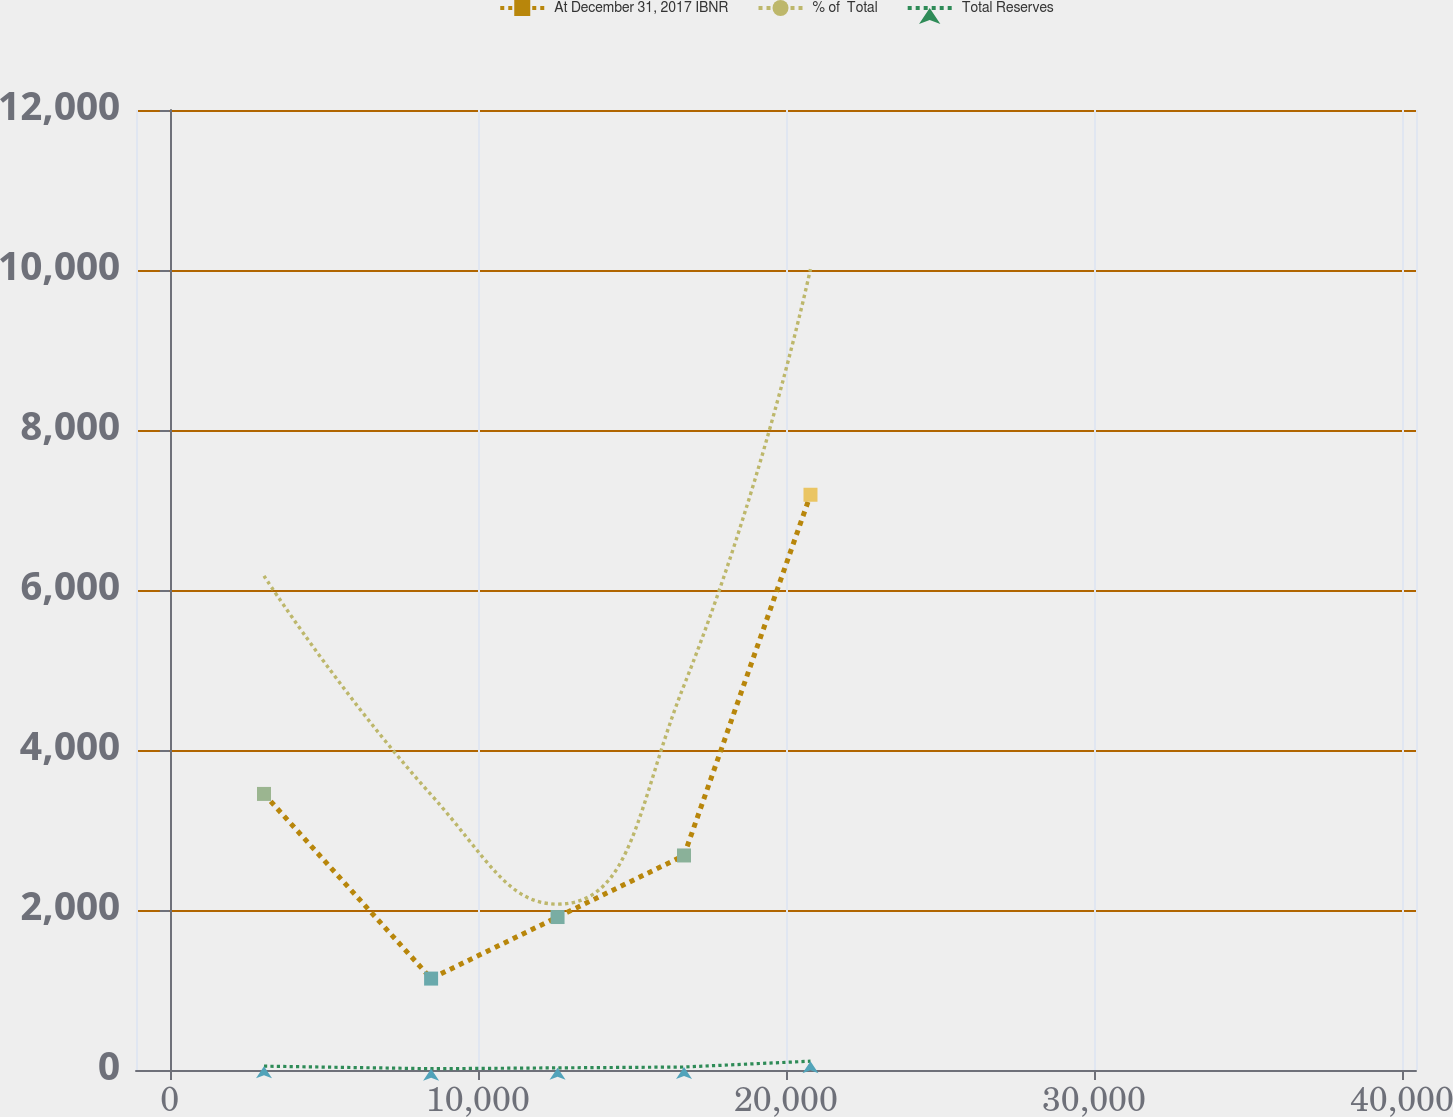<chart> <loc_0><loc_0><loc_500><loc_500><line_chart><ecel><fcel>At December 31, 2017 IBNR<fcel>% of  Total<fcel>Total Reserves<nl><fcel>3058.61<fcel>3450.98<fcel>6175.96<fcel>48.07<nl><fcel>8483.27<fcel>1142.66<fcel>3440.62<fcel>16.03<nl><fcel>12588.6<fcel>1912.1<fcel>2072.95<fcel>26.71<nl><fcel>16694<fcel>2681.54<fcel>4808.29<fcel>37.39<nl><fcel>20799.4<fcel>7190.62<fcel>10012<fcel>110.18<nl><fcel>40506.3<fcel>152.59<fcel>501.85<fcel>3.42<nl><fcel>44611.7<fcel>7960.06<fcel>14178.5<fcel>95.93<nl></chart> 